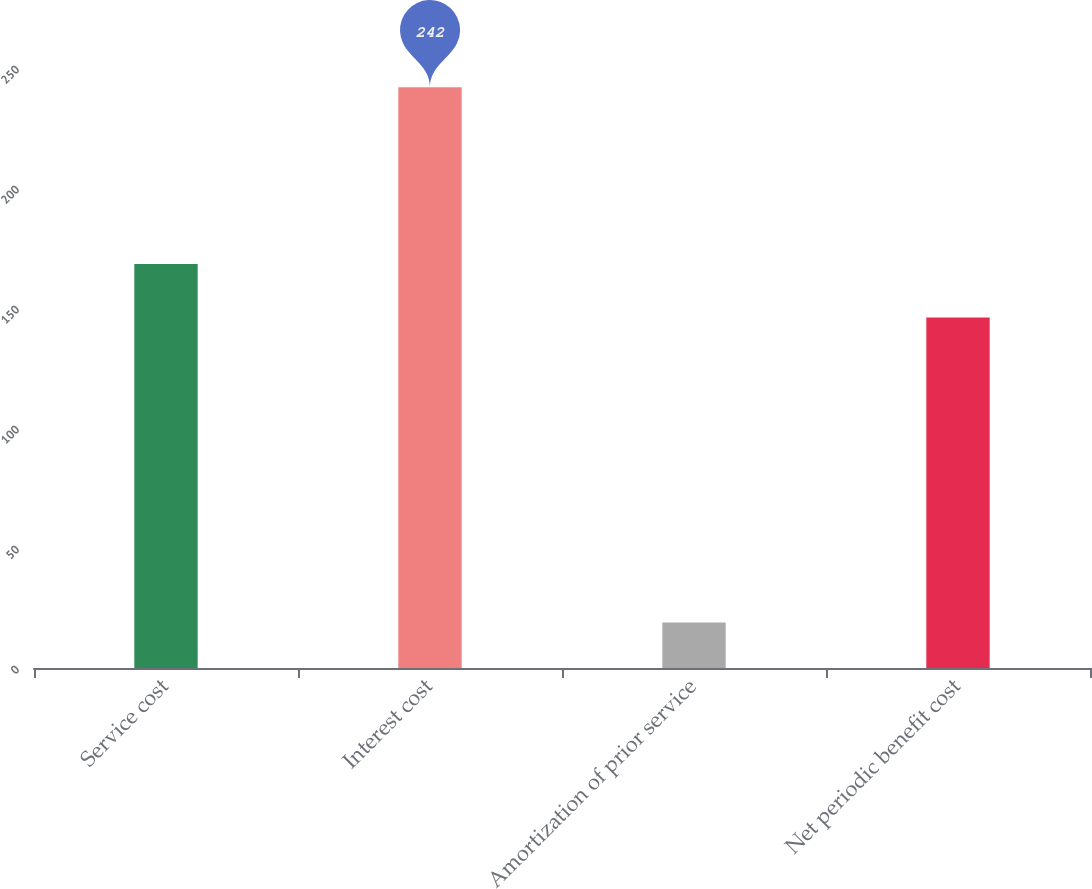<chart> <loc_0><loc_0><loc_500><loc_500><bar_chart><fcel>Service cost<fcel>Interest cost<fcel>Amortization of prior service<fcel>Net periodic benefit cost<nl><fcel>168.3<fcel>242<fcel>19<fcel>146<nl></chart> 